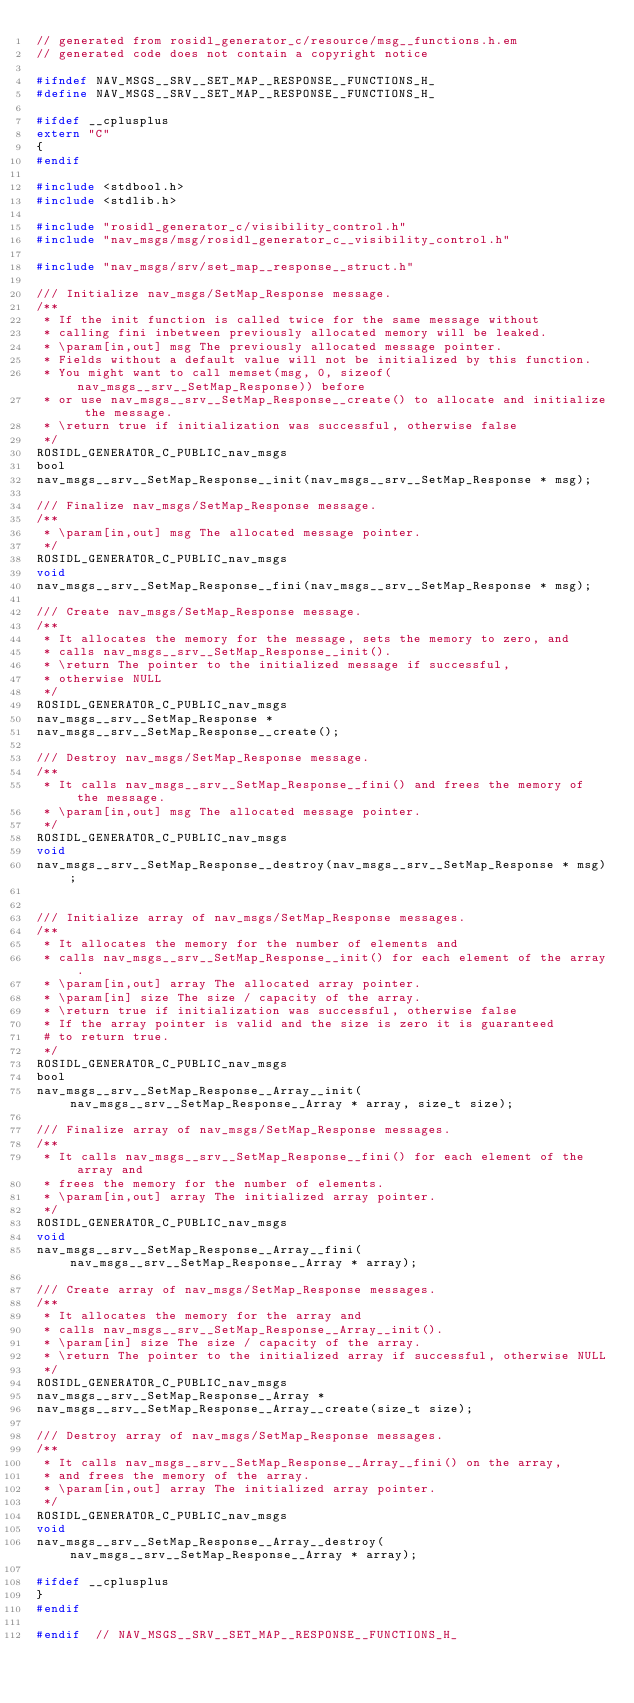<code> <loc_0><loc_0><loc_500><loc_500><_C_>// generated from rosidl_generator_c/resource/msg__functions.h.em
// generated code does not contain a copyright notice

#ifndef NAV_MSGS__SRV__SET_MAP__RESPONSE__FUNCTIONS_H_
#define NAV_MSGS__SRV__SET_MAP__RESPONSE__FUNCTIONS_H_

#ifdef __cplusplus
extern "C"
{
#endif

#include <stdbool.h>
#include <stdlib.h>

#include "rosidl_generator_c/visibility_control.h"
#include "nav_msgs/msg/rosidl_generator_c__visibility_control.h"

#include "nav_msgs/srv/set_map__response__struct.h"

/// Initialize nav_msgs/SetMap_Response message.
/**
 * If the init function is called twice for the same message without
 * calling fini inbetween previously allocated memory will be leaked.
 * \param[in,out] msg The previously allocated message pointer.
 * Fields without a default value will not be initialized by this function.
 * You might want to call memset(msg, 0, sizeof(nav_msgs__srv__SetMap_Response)) before
 * or use nav_msgs__srv__SetMap_Response__create() to allocate and initialize the message.
 * \return true if initialization was successful, otherwise false
 */
ROSIDL_GENERATOR_C_PUBLIC_nav_msgs
bool
nav_msgs__srv__SetMap_Response__init(nav_msgs__srv__SetMap_Response * msg);

/// Finalize nav_msgs/SetMap_Response message.
/**
 * \param[in,out] msg The allocated message pointer.
 */
ROSIDL_GENERATOR_C_PUBLIC_nav_msgs
void
nav_msgs__srv__SetMap_Response__fini(nav_msgs__srv__SetMap_Response * msg);

/// Create nav_msgs/SetMap_Response message.
/**
 * It allocates the memory for the message, sets the memory to zero, and
 * calls nav_msgs__srv__SetMap_Response__init().
 * \return The pointer to the initialized message if successful,
 * otherwise NULL
 */
ROSIDL_GENERATOR_C_PUBLIC_nav_msgs
nav_msgs__srv__SetMap_Response *
nav_msgs__srv__SetMap_Response__create();

/// Destroy nav_msgs/SetMap_Response message.
/**
 * It calls nav_msgs__srv__SetMap_Response__fini() and frees the memory of the message.
 * \param[in,out] msg The allocated message pointer.
 */
ROSIDL_GENERATOR_C_PUBLIC_nav_msgs
void
nav_msgs__srv__SetMap_Response__destroy(nav_msgs__srv__SetMap_Response * msg);


/// Initialize array of nav_msgs/SetMap_Response messages.
/**
 * It allocates the memory for the number of elements and
 * calls nav_msgs__srv__SetMap_Response__init() for each element of the array.
 * \param[in,out] array The allocated array pointer.
 * \param[in] size The size / capacity of the array.
 * \return true if initialization was successful, otherwise false
 * If the array pointer is valid and the size is zero it is guaranteed
 # to return true.
 */
ROSIDL_GENERATOR_C_PUBLIC_nav_msgs
bool
nav_msgs__srv__SetMap_Response__Array__init(nav_msgs__srv__SetMap_Response__Array * array, size_t size);

/// Finalize array of nav_msgs/SetMap_Response messages.
/**
 * It calls nav_msgs__srv__SetMap_Response__fini() for each element of the array and
 * frees the memory for the number of elements.
 * \param[in,out] array The initialized array pointer.
 */
ROSIDL_GENERATOR_C_PUBLIC_nav_msgs
void
nav_msgs__srv__SetMap_Response__Array__fini(nav_msgs__srv__SetMap_Response__Array * array);

/// Create array of nav_msgs/SetMap_Response messages.
/**
 * It allocates the memory for the array and
 * calls nav_msgs__srv__SetMap_Response__Array__init().
 * \param[in] size The size / capacity of the array.
 * \return The pointer to the initialized array if successful, otherwise NULL
 */
ROSIDL_GENERATOR_C_PUBLIC_nav_msgs
nav_msgs__srv__SetMap_Response__Array *
nav_msgs__srv__SetMap_Response__Array__create(size_t size);

/// Destroy array of nav_msgs/SetMap_Response messages.
/**
 * It calls nav_msgs__srv__SetMap_Response__Array__fini() on the array,
 * and frees the memory of the array.
 * \param[in,out] array The initialized array pointer.
 */
ROSIDL_GENERATOR_C_PUBLIC_nav_msgs
void
nav_msgs__srv__SetMap_Response__Array__destroy(nav_msgs__srv__SetMap_Response__Array * array);

#ifdef __cplusplus
}
#endif

#endif  // NAV_MSGS__SRV__SET_MAP__RESPONSE__FUNCTIONS_H_
</code> 